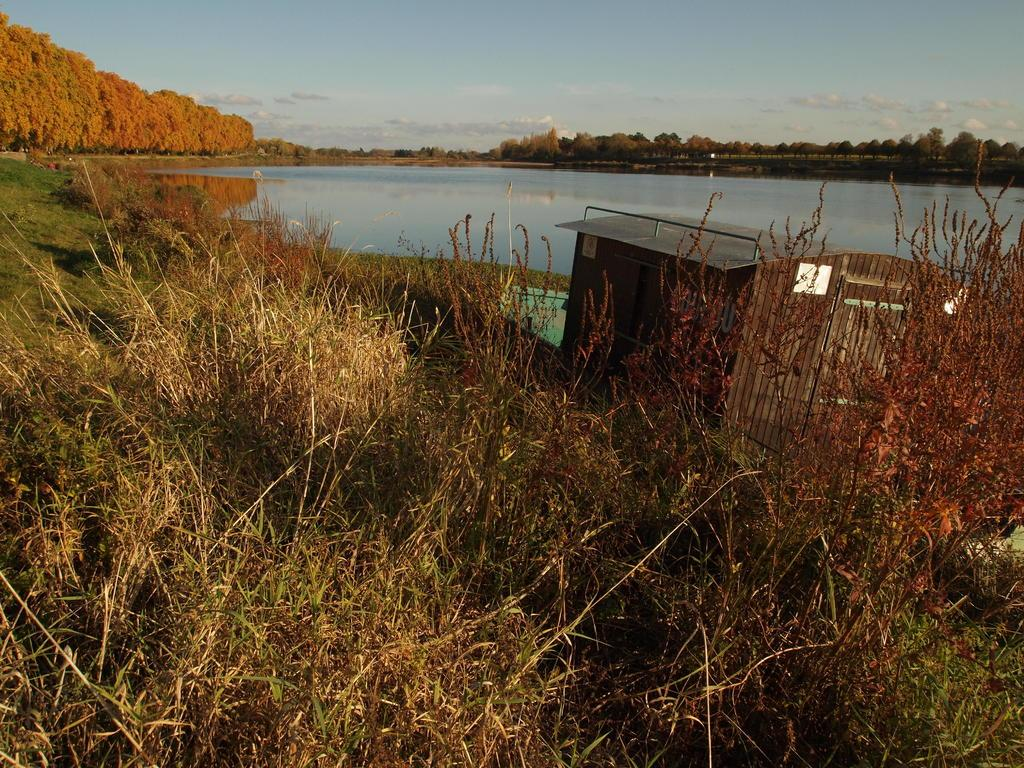What type of vegetation is present in the image? There is grass in the image. What structure can be seen to the right of the image? There is a shed to the right of the image. What can be seen in the distance in the image? There is water visible in the background of the image. What other natural elements are present in the background of the image? There are many trees and clouds in the background of the image. What part of the sky is visible in the image? The sky is visible in the background of the image. Can you see your friend sitting on a shelf in the image? There is no friend or shelf present in the image. 